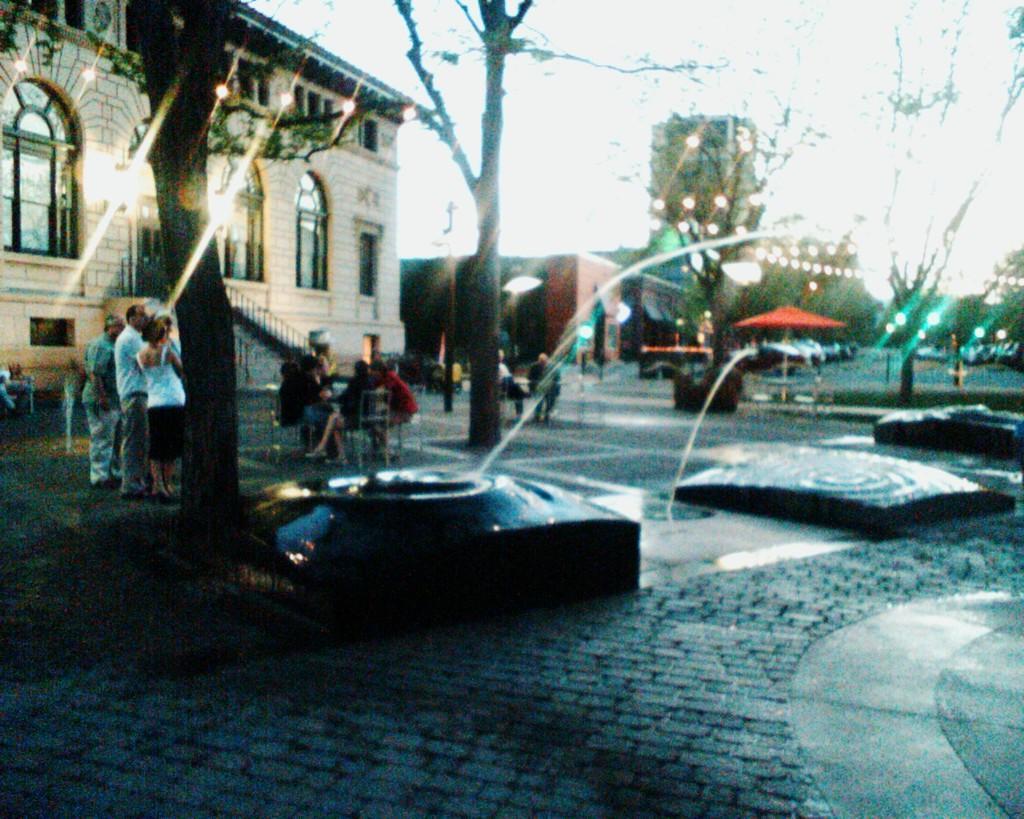Please provide a concise description of this image. In the picture I can see few black color objects and there are few trees beside it and there are group of people where few among them are sitting in chairs and the remaining are standing and there is a building in the left corner and there are few other buildings,trees,vehicles,decorative lights and some other objects in the background. 